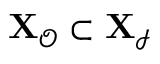<formula> <loc_0><loc_0><loc_500><loc_500>{ X } _ { \mathcal { O } } \subset X _ { \mathcal { I } }</formula> 